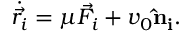Convert formula to latex. <formula><loc_0><loc_0><loc_500><loc_500>\dot { \vec { r _ { i } } } = \mu \vec { F _ { i } } + v _ { 0 } \hat { n } _ { i } .</formula> 